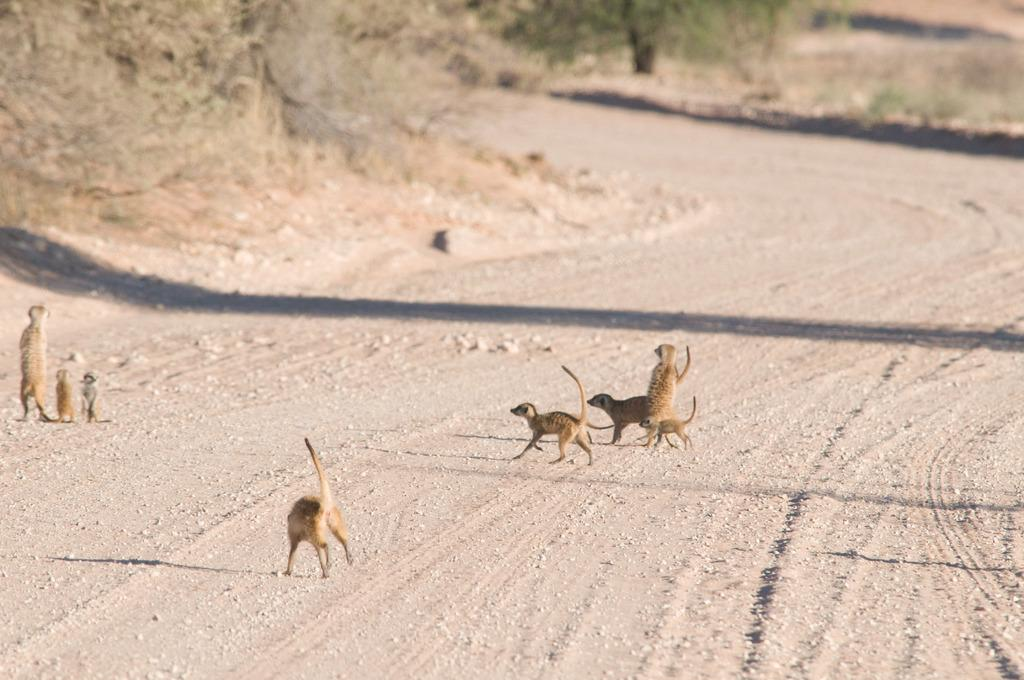What is located in the center of the image? There are animals in the center of the image. What is at the bottom of the image? There is a walkway at the bottom of the image. What can be seen in the background of the image? There are trees and dry grass in the background of the image. How much money is the guide holding in the image? There is no guide or money present in the image. What type of wrench is being used by the animals in the image? There are no wrenches or tools present in the image; it features animals and a walkway. 